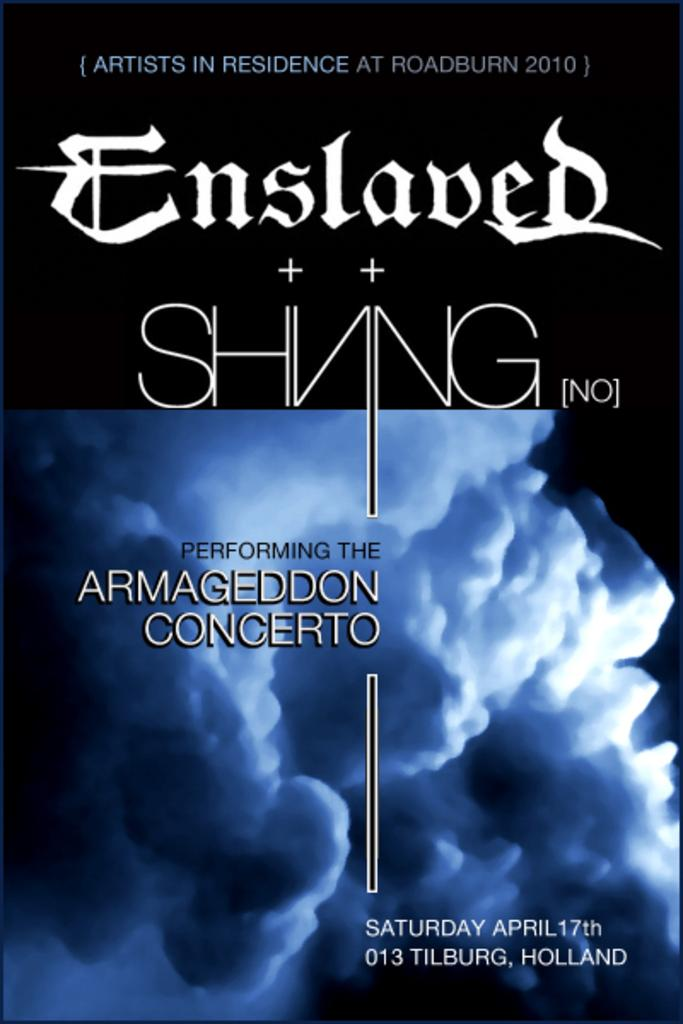<image>
Describe the image concisely. Slaved performing the Armageddon concerto on Saturday in April 